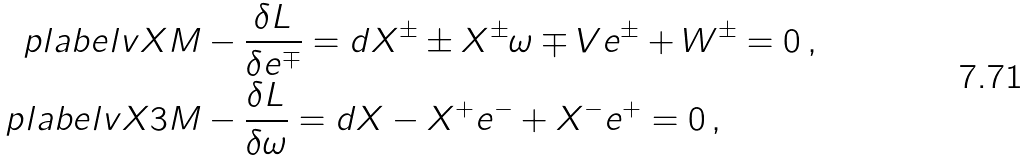Convert formula to latex. <formula><loc_0><loc_0><loc_500><loc_500>\ p l a b e l { v X M } & - \frac { \delta L } { \delta e ^ { \mp } } = d X ^ { \pm } \pm X ^ { \pm } \omega \mp V e ^ { \pm } + W ^ { \pm } = 0 \, , \\ \ p l a b e l { v X 3 M } & - \frac { \delta L } { \delta \omega } = d X - X ^ { + } e ^ { - } + X ^ { - } e ^ { + } = 0 \, ,</formula> 